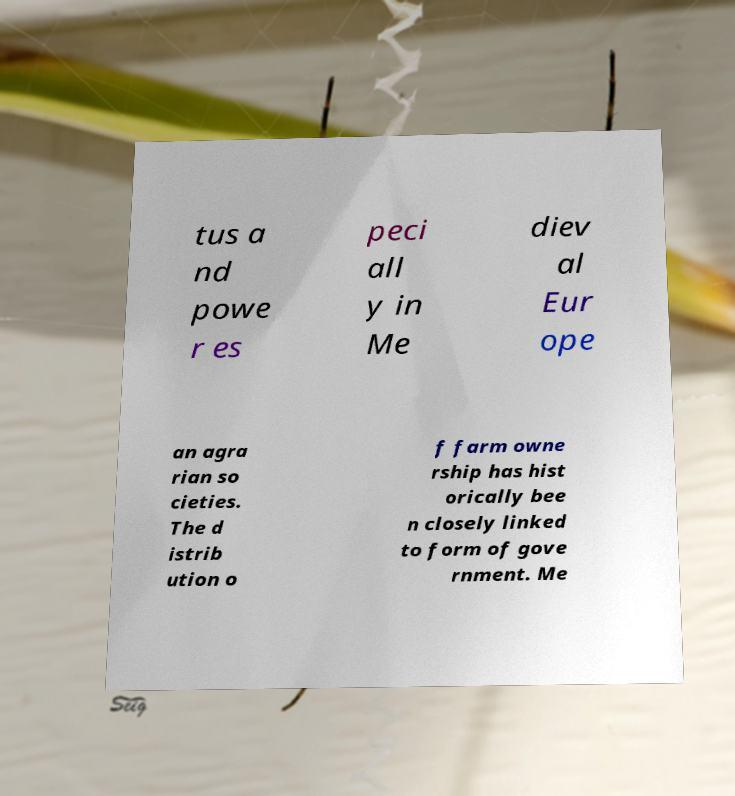Please identify and transcribe the text found in this image. tus a nd powe r es peci all y in Me diev al Eur ope an agra rian so cieties. The d istrib ution o f farm owne rship has hist orically bee n closely linked to form of gove rnment. Me 